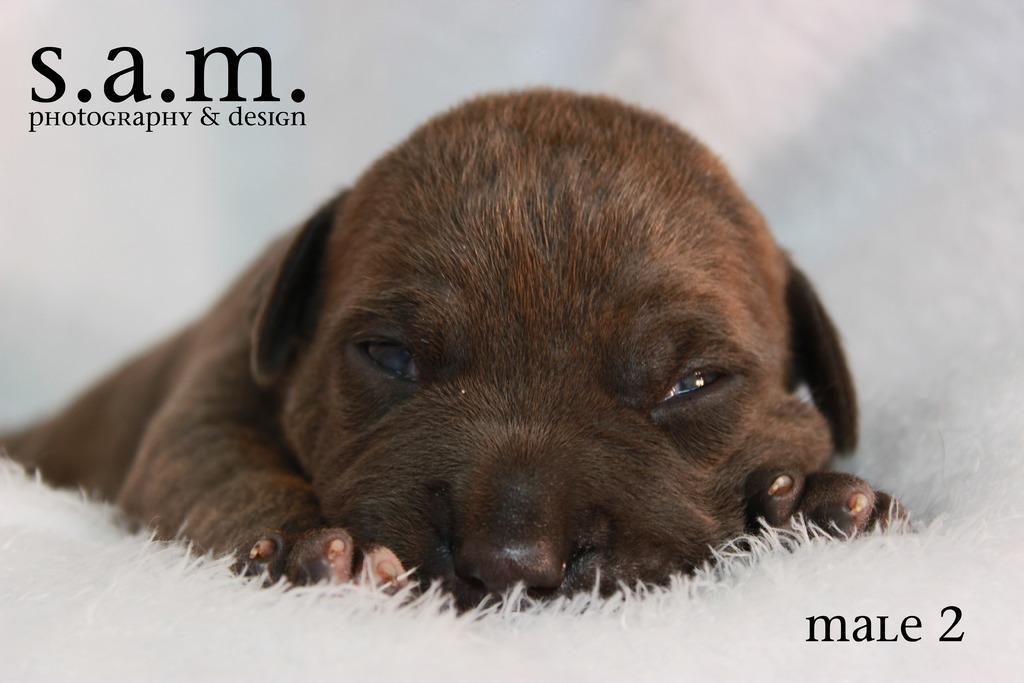Please provide a concise description of this image. It is the picture in which there is a dog sleeping on the white color pillow. 